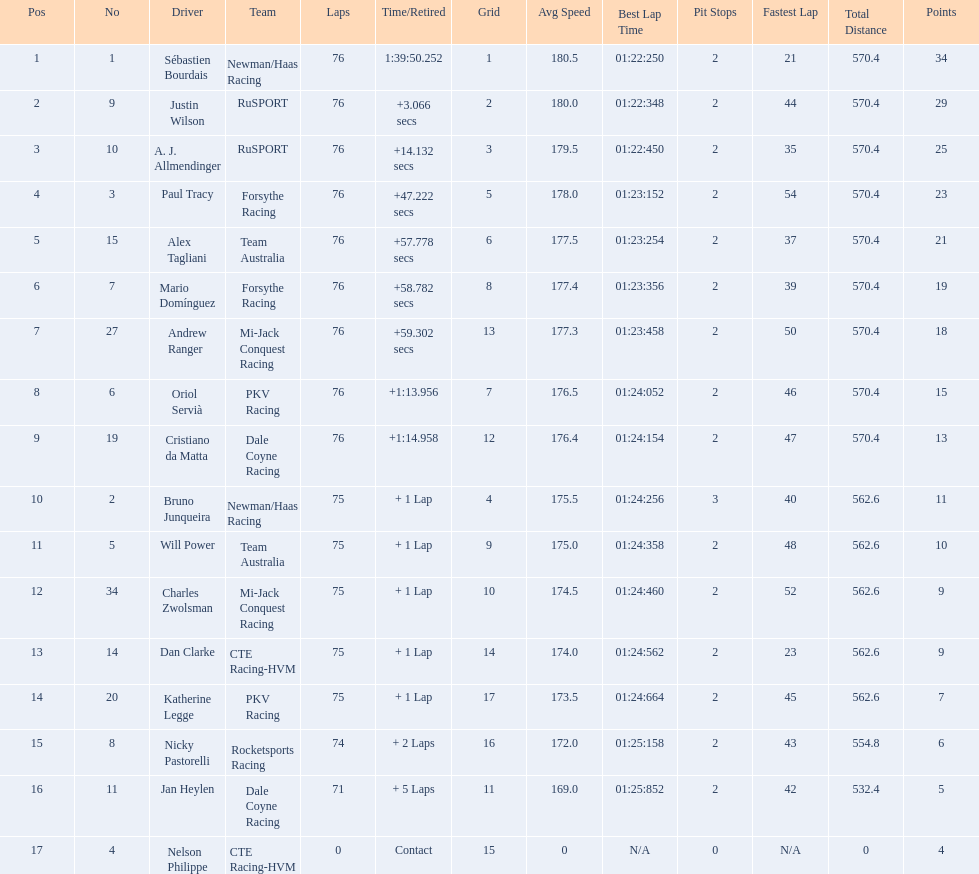Who drove during the 2006 tecate grand prix of monterrey? Sébastien Bourdais, Justin Wilson, A. J. Allmendinger, Paul Tracy, Alex Tagliani, Mario Domínguez, Andrew Ranger, Oriol Servià, Cristiano da Matta, Bruno Junqueira, Will Power, Charles Zwolsman, Dan Clarke, Katherine Legge, Nicky Pastorelli, Jan Heylen, Nelson Philippe. And what were their finishing positions? 1, 2, 3, 4, 5, 6, 7, 8, 9, 10, 11, 12, 13, 14, 15, 16, 17. Who did alex tagliani finish directly behind of? Paul Tracy. 